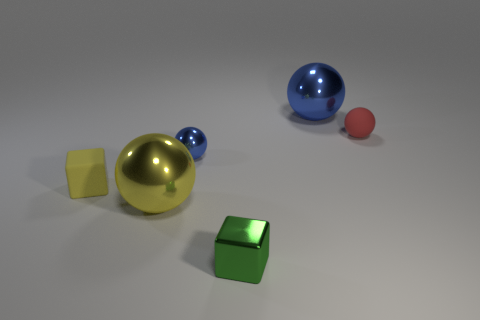How does the size of the green cube compare to the other objects in the image? The green cube is medium-sized in comparison to the other objects; it's larger than the tiny yellow cube and the small red sphere, but smaller than the large gold sphere and the large blue sphere. 